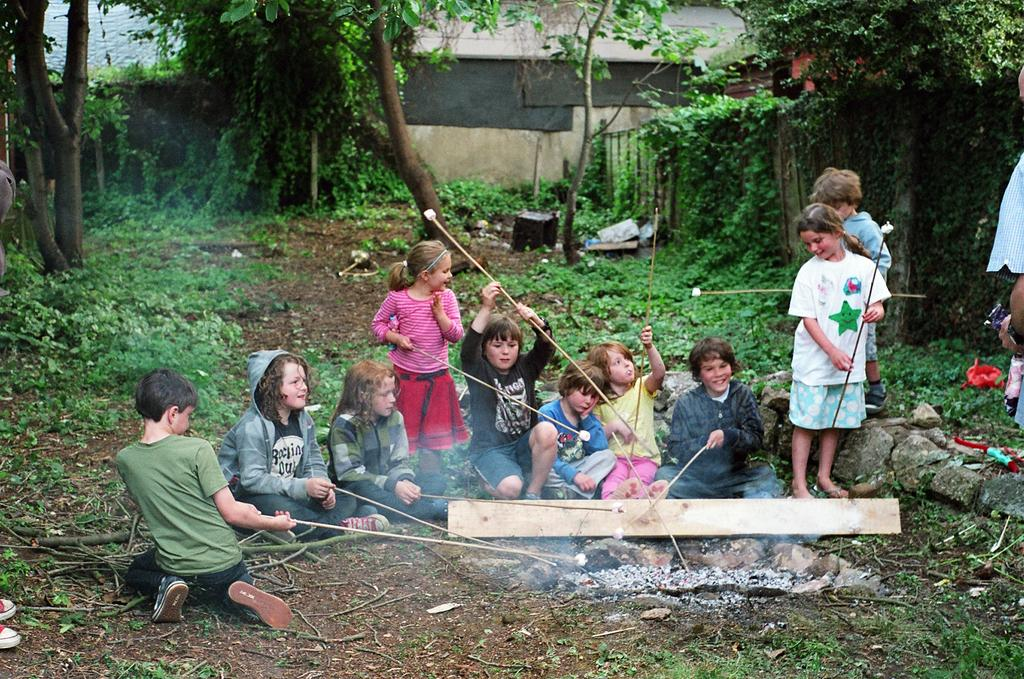What is the main subject in the middle of the image? There is a group of children sitting in the middle of the image. What is happening in the middle of the image? There is a fire in the middle of the image. What can be seen on either side of the image? There are trees on either side of the image. What is visible at the top of the image? The top of the image features a wall. What type of birthday celebration is happening in the image? There is no indication of a birthday celebration in the image. How does the wall curve around the children in the image? The wall does not curve around the children in the image; it is a straight wall at the top of the image. 